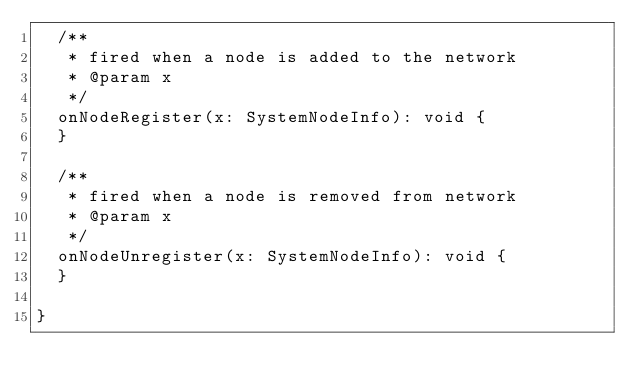<code> <loc_0><loc_0><loc_500><loc_500><_TypeScript_>  /**
   * fired when a node is added to the network
   * @param x
   */
  onNodeRegister(x: SystemNodeInfo): void {
  }

  /**
   * fired when a node is removed from network
   * @param x
   */
  onNodeUnregister(x: SystemNodeInfo): void {
  }

}
</code> 